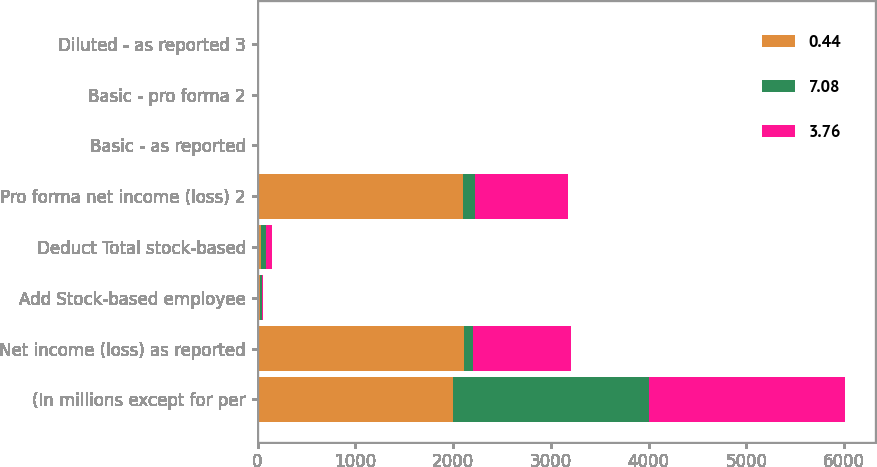<chart> <loc_0><loc_0><loc_500><loc_500><stacked_bar_chart><ecel><fcel>(In millions except for per<fcel>Net income (loss) as reported<fcel>Add Stock-based employee<fcel>Deduct Total stock-based<fcel>Pro forma net income (loss) 2<fcel>Basic - as reported<fcel>Basic - pro forma 2<fcel>Diluted - as reported 3<nl><fcel>0.44<fcel>2004<fcel>2115<fcel>27<fcel>38<fcel>2104<fcel>7.24<fcel>7.2<fcel>7.12<nl><fcel>7.08<fcel>2003<fcel>91<fcel>20<fcel>50<fcel>121<fcel>0.33<fcel>0.44<fcel>0.33<nl><fcel>3.76<fcel>2002<fcel>1000<fcel>6<fcel>59<fcel>947<fcel>4.01<fcel>3.8<fcel>3.97<nl></chart> 